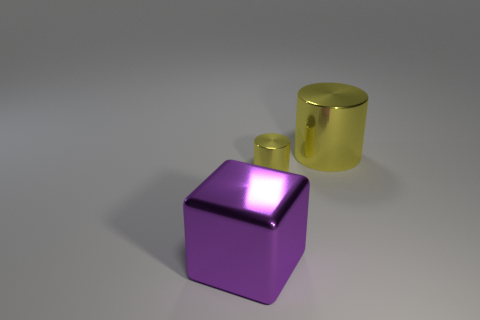How many other objects are the same color as the big metal cube?
Make the answer very short. 0. There is a small metallic object; how many big purple metallic blocks are behind it?
Make the answer very short. 0. Are there any other purple objects of the same size as the purple thing?
Keep it short and to the point. No. Does the big cylinder have the same color as the small metallic cylinder?
Ensure brevity in your answer.  Yes. The metallic cylinder that is in front of the large metallic thing that is to the right of the big purple metallic cube is what color?
Give a very brief answer. Yellow. What number of metallic objects are behind the big purple metallic thing and on the left side of the large yellow cylinder?
Offer a terse response. 1. What number of other objects have the same shape as the tiny shiny object?
Ensure brevity in your answer.  1. There is a yellow thing in front of the big shiny thing that is right of the big purple object; what is its shape?
Your response must be concise. Cylinder. There is a object in front of the tiny yellow shiny thing; how many shiny objects are in front of it?
Provide a short and direct response. 0. What is the shape of the yellow metal thing that is the same size as the purple metal block?
Offer a terse response. Cylinder. 